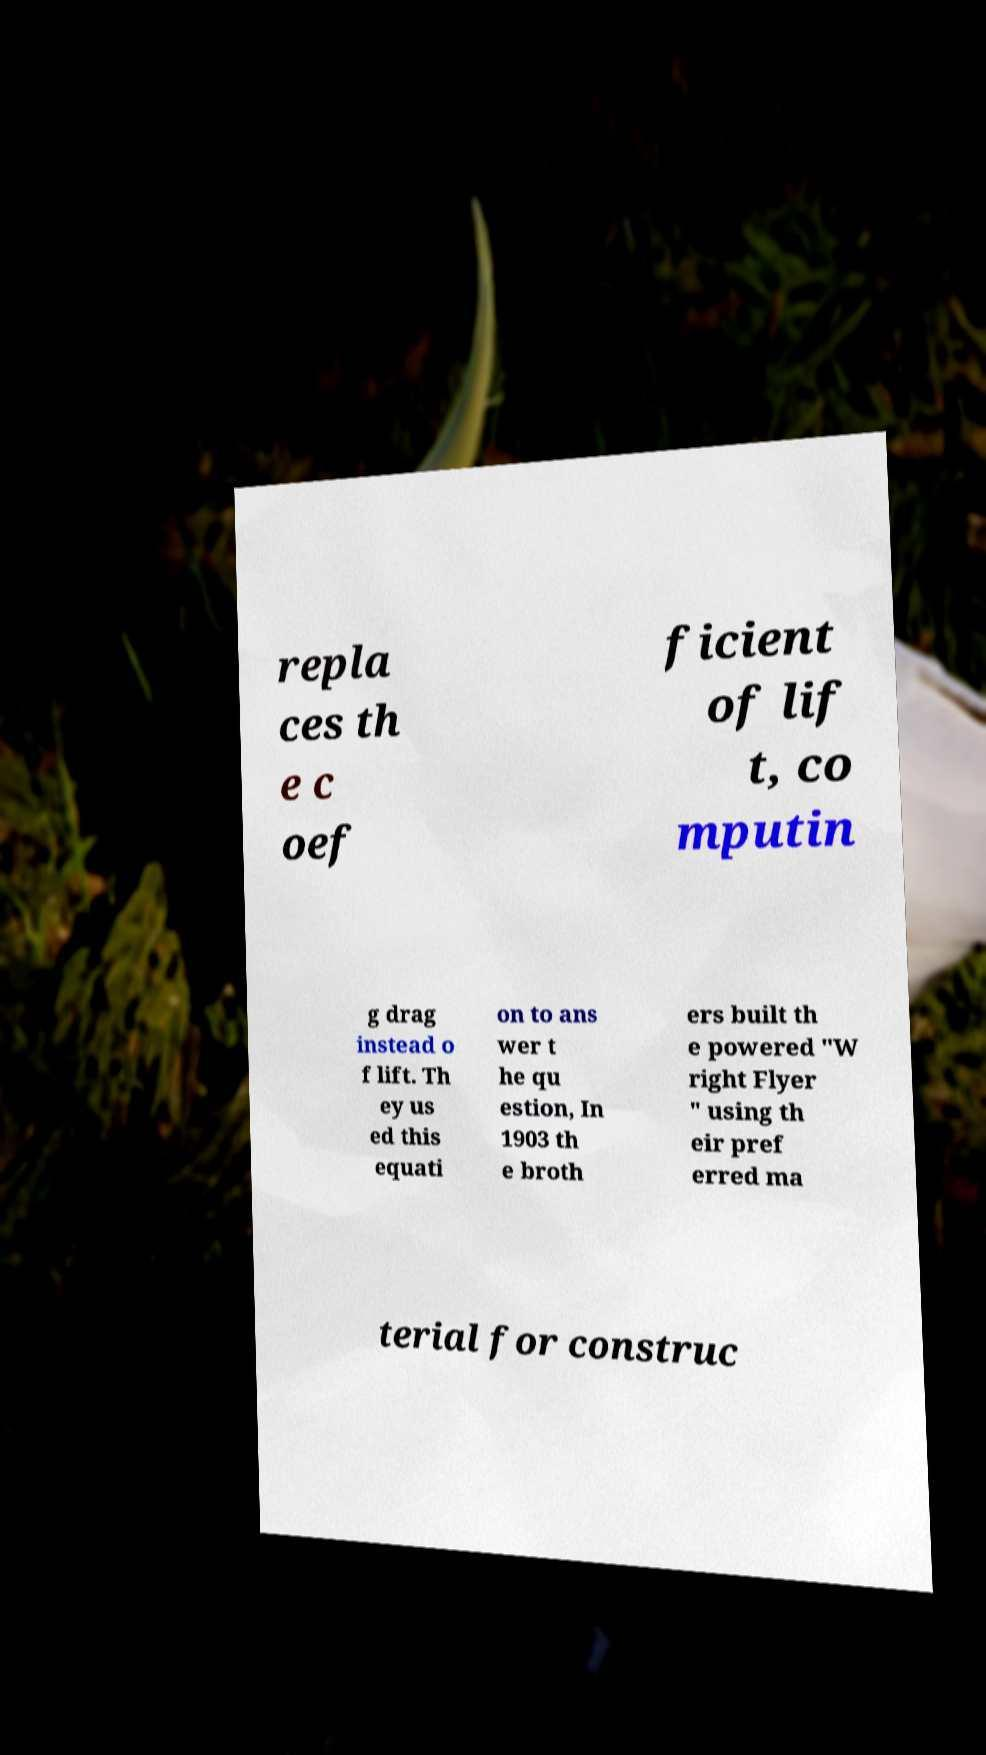Could you extract and type out the text from this image? repla ces th e c oef ficient of lif t, co mputin g drag instead o f lift. Th ey us ed this equati on to ans wer t he qu estion, In 1903 th e broth ers built th e powered "W right Flyer " using th eir pref erred ma terial for construc 